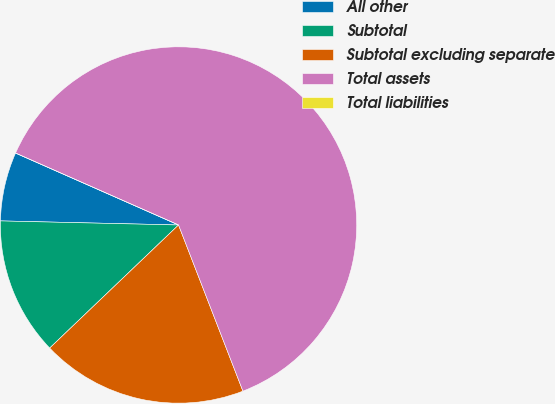Convert chart to OTSL. <chart><loc_0><loc_0><loc_500><loc_500><pie_chart><fcel>All other<fcel>Subtotal<fcel>Subtotal excluding separate<fcel>Total assets<fcel>Total liabilities<nl><fcel>6.25%<fcel>12.5%<fcel>18.75%<fcel>62.5%<fcel>0.0%<nl></chart> 